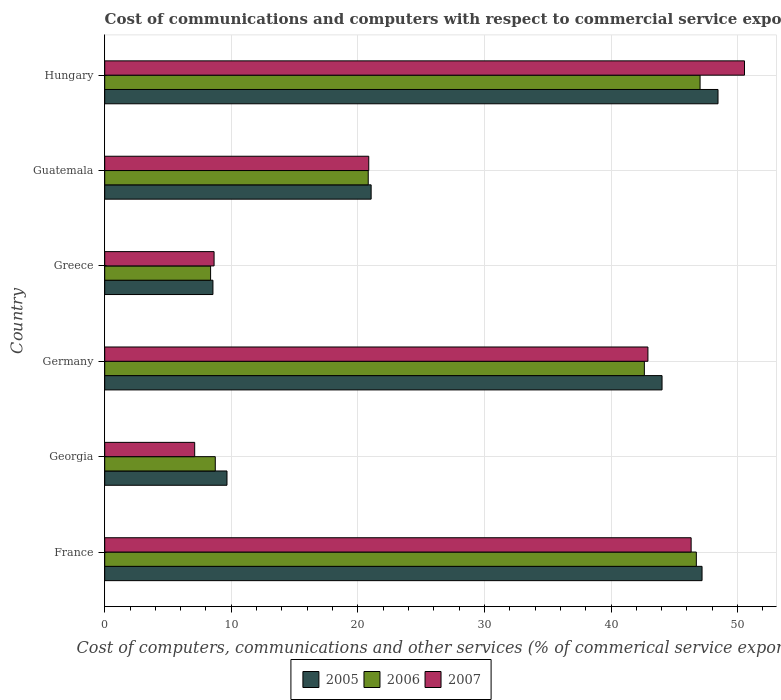How many different coloured bars are there?
Your response must be concise. 3. Are the number of bars on each tick of the Y-axis equal?
Provide a short and direct response. Yes. How many bars are there on the 6th tick from the top?
Provide a short and direct response. 3. How many bars are there on the 5th tick from the bottom?
Give a very brief answer. 3. What is the label of the 4th group of bars from the top?
Ensure brevity in your answer.  Germany. In how many cases, is the number of bars for a given country not equal to the number of legend labels?
Provide a succinct answer. 0. What is the cost of communications and computers in 2005 in Germany?
Provide a short and direct response. 44.03. Across all countries, what is the maximum cost of communications and computers in 2005?
Offer a terse response. 48.46. Across all countries, what is the minimum cost of communications and computers in 2005?
Offer a terse response. 8.55. In which country was the cost of communications and computers in 2005 maximum?
Give a very brief answer. Hungary. In which country was the cost of communications and computers in 2007 minimum?
Your answer should be compact. Georgia. What is the total cost of communications and computers in 2006 in the graph?
Give a very brief answer. 174.34. What is the difference between the cost of communications and computers in 2005 in Georgia and that in Guatemala?
Ensure brevity in your answer.  -11.39. What is the difference between the cost of communications and computers in 2006 in Guatemala and the cost of communications and computers in 2007 in Greece?
Provide a succinct answer. 12.18. What is the average cost of communications and computers in 2006 per country?
Make the answer very short. 29.06. What is the difference between the cost of communications and computers in 2006 and cost of communications and computers in 2005 in Germany?
Your response must be concise. -1.4. What is the ratio of the cost of communications and computers in 2007 in Germany to that in Greece?
Provide a succinct answer. 4.97. Is the difference between the cost of communications and computers in 2006 in Greece and Hungary greater than the difference between the cost of communications and computers in 2005 in Greece and Hungary?
Ensure brevity in your answer.  Yes. What is the difference between the highest and the second highest cost of communications and computers in 2006?
Provide a short and direct response. 0.3. What is the difference between the highest and the lowest cost of communications and computers in 2005?
Your answer should be very brief. 39.9. What does the 3rd bar from the bottom in Germany represents?
Provide a succinct answer. 2007. Is it the case that in every country, the sum of the cost of communications and computers in 2005 and cost of communications and computers in 2007 is greater than the cost of communications and computers in 2006?
Ensure brevity in your answer.  Yes. Are all the bars in the graph horizontal?
Offer a very short reply. Yes. Does the graph contain any zero values?
Give a very brief answer. No. Does the graph contain grids?
Ensure brevity in your answer.  Yes. How are the legend labels stacked?
Keep it short and to the point. Horizontal. What is the title of the graph?
Your response must be concise. Cost of communications and computers with respect to commercial service exports. What is the label or title of the X-axis?
Keep it short and to the point. Cost of computers, communications and other services (% of commerical service exports). What is the label or title of the Y-axis?
Offer a very short reply. Country. What is the Cost of computers, communications and other services (% of commerical service exports) in 2005 in France?
Give a very brief answer. 47.19. What is the Cost of computers, communications and other services (% of commerical service exports) of 2006 in France?
Give a very brief answer. 46.74. What is the Cost of computers, communications and other services (% of commerical service exports) of 2007 in France?
Ensure brevity in your answer.  46.33. What is the Cost of computers, communications and other services (% of commerical service exports) in 2005 in Georgia?
Provide a succinct answer. 9.66. What is the Cost of computers, communications and other services (% of commerical service exports) in 2006 in Georgia?
Give a very brief answer. 8.74. What is the Cost of computers, communications and other services (% of commerical service exports) in 2007 in Georgia?
Make the answer very short. 7.11. What is the Cost of computers, communications and other services (% of commerical service exports) of 2005 in Germany?
Your answer should be compact. 44.03. What is the Cost of computers, communications and other services (% of commerical service exports) in 2006 in Germany?
Give a very brief answer. 42.64. What is the Cost of computers, communications and other services (% of commerical service exports) of 2007 in Germany?
Ensure brevity in your answer.  42.92. What is the Cost of computers, communications and other services (% of commerical service exports) in 2005 in Greece?
Give a very brief answer. 8.55. What is the Cost of computers, communications and other services (% of commerical service exports) of 2006 in Greece?
Your answer should be very brief. 8.36. What is the Cost of computers, communications and other services (% of commerical service exports) in 2007 in Greece?
Give a very brief answer. 8.64. What is the Cost of computers, communications and other services (% of commerical service exports) of 2005 in Guatemala?
Your response must be concise. 21.05. What is the Cost of computers, communications and other services (% of commerical service exports) in 2006 in Guatemala?
Provide a succinct answer. 20.82. What is the Cost of computers, communications and other services (% of commerical service exports) in 2007 in Guatemala?
Keep it short and to the point. 20.86. What is the Cost of computers, communications and other services (% of commerical service exports) of 2005 in Hungary?
Provide a short and direct response. 48.46. What is the Cost of computers, communications and other services (% of commerical service exports) of 2006 in Hungary?
Offer a very short reply. 47.04. What is the Cost of computers, communications and other services (% of commerical service exports) of 2007 in Hungary?
Provide a succinct answer. 50.55. Across all countries, what is the maximum Cost of computers, communications and other services (% of commerical service exports) of 2005?
Offer a terse response. 48.46. Across all countries, what is the maximum Cost of computers, communications and other services (% of commerical service exports) in 2006?
Keep it short and to the point. 47.04. Across all countries, what is the maximum Cost of computers, communications and other services (% of commerical service exports) in 2007?
Your answer should be compact. 50.55. Across all countries, what is the minimum Cost of computers, communications and other services (% of commerical service exports) in 2005?
Give a very brief answer. 8.55. Across all countries, what is the minimum Cost of computers, communications and other services (% of commerical service exports) in 2006?
Give a very brief answer. 8.36. Across all countries, what is the minimum Cost of computers, communications and other services (% of commerical service exports) of 2007?
Your answer should be very brief. 7.11. What is the total Cost of computers, communications and other services (% of commerical service exports) of 2005 in the graph?
Your response must be concise. 178.94. What is the total Cost of computers, communications and other services (% of commerical service exports) of 2006 in the graph?
Provide a short and direct response. 174.34. What is the total Cost of computers, communications and other services (% of commerical service exports) of 2007 in the graph?
Your answer should be compact. 176.41. What is the difference between the Cost of computers, communications and other services (% of commerical service exports) in 2005 in France and that in Georgia?
Offer a very short reply. 37.53. What is the difference between the Cost of computers, communications and other services (% of commerical service exports) in 2006 in France and that in Georgia?
Provide a succinct answer. 38.01. What is the difference between the Cost of computers, communications and other services (% of commerical service exports) in 2007 in France and that in Georgia?
Your answer should be very brief. 39.22. What is the difference between the Cost of computers, communications and other services (% of commerical service exports) in 2005 in France and that in Germany?
Your response must be concise. 3.16. What is the difference between the Cost of computers, communications and other services (% of commerical service exports) in 2006 in France and that in Germany?
Keep it short and to the point. 4.11. What is the difference between the Cost of computers, communications and other services (% of commerical service exports) of 2007 in France and that in Germany?
Offer a very short reply. 3.41. What is the difference between the Cost of computers, communications and other services (% of commerical service exports) in 2005 in France and that in Greece?
Give a very brief answer. 38.64. What is the difference between the Cost of computers, communications and other services (% of commerical service exports) in 2006 in France and that in Greece?
Provide a short and direct response. 38.38. What is the difference between the Cost of computers, communications and other services (% of commerical service exports) in 2007 in France and that in Greece?
Keep it short and to the point. 37.69. What is the difference between the Cost of computers, communications and other services (% of commerical service exports) of 2005 in France and that in Guatemala?
Give a very brief answer. 26.14. What is the difference between the Cost of computers, communications and other services (% of commerical service exports) in 2006 in France and that in Guatemala?
Offer a very short reply. 25.92. What is the difference between the Cost of computers, communications and other services (% of commerical service exports) of 2007 in France and that in Guatemala?
Provide a short and direct response. 25.47. What is the difference between the Cost of computers, communications and other services (% of commerical service exports) of 2005 in France and that in Hungary?
Provide a succinct answer. -1.26. What is the difference between the Cost of computers, communications and other services (% of commerical service exports) of 2006 in France and that in Hungary?
Your response must be concise. -0.3. What is the difference between the Cost of computers, communications and other services (% of commerical service exports) in 2007 in France and that in Hungary?
Make the answer very short. -4.22. What is the difference between the Cost of computers, communications and other services (% of commerical service exports) of 2005 in Georgia and that in Germany?
Give a very brief answer. -34.37. What is the difference between the Cost of computers, communications and other services (% of commerical service exports) in 2006 in Georgia and that in Germany?
Provide a succinct answer. -33.9. What is the difference between the Cost of computers, communications and other services (% of commerical service exports) of 2007 in Georgia and that in Germany?
Provide a succinct answer. -35.81. What is the difference between the Cost of computers, communications and other services (% of commerical service exports) in 2005 in Georgia and that in Greece?
Your answer should be very brief. 1.11. What is the difference between the Cost of computers, communications and other services (% of commerical service exports) in 2006 in Georgia and that in Greece?
Your response must be concise. 0.37. What is the difference between the Cost of computers, communications and other services (% of commerical service exports) of 2007 in Georgia and that in Greece?
Provide a succinct answer. -1.53. What is the difference between the Cost of computers, communications and other services (% of commerical service exports) of 2005 in Georgia and that in Guatemala?
Provide a short and direct response. -11.39. What is the difference between the Cost of computers, communications and other services (% of commerical service exports) in 2006 in Georgia and that in Guatemala?
Ensure brevity in your answer.  -12.08. What is the difference between the Cost of computers, communications and other services (% of commerical service exports) in 2007 in Georgia and that in Guatemala?
Provide a succinct answer. -13.75. What is the difference between the Cost of computers, communications and other services (% of commerical service exports) of 2005 in Georgia and that in Hungary?
Give a very brief answer. -38.8. What is the difference between the Cost of computers, communications and other services (% of commerical service exports) in 2006 in Georgia and that in Hungary?
Provide a succinct answer. -38.3. What is the difference between the Cost of computers, communications and other services (% of commerical service exports) in 2007 in Georgia and that in Hungary?
Your response must be concise. -43.44. What is the difference between the Cost of computers, communications and other services (% of commerical service exports) of 2005 in Germany and that in Greece?
Make the answer very short. 35.48. What is the difference between the Cost of computers, communications and other services (% of commerical service exports) of 2006 in Germany and that in Greece?
Offer a very short reply. 34.27. What is the difference between the Cost of computers, communications and other services (% of commerical service exports) in 2007 in Germany and that in Greece?
Keep it short and to the point. 34.28. What is the difference between the Cost of computers, communications and other services (% of commerical service exports) in 2005 in Germany and that in Guatemala?
Provide a succinct answer. 22.98. What is the difference between the Cost of computers, communications and other services (% of commerical service exports) of 2006 in Germany and that in Guatemala?
Provide a short and direct response. 21.82. What is the difference between the Cost of computers, communications and other services (% of commerical service exports) in 2007 in Germany and that in Guatemala?
Your answer should be very brief. 22.06. What is the difference between the Cost of computers, communications and other services (% of commerical service exports) in 2005 in Germany and that in Hungary?
Give a very brief answer. -4.42. What is the difference between the Cost of computers, communications and other services (% of commerical service exports) in 2006 in Germany and that in Hungary?
Your response must be concise. -4.4. What is the difference between the Cost of computers, communications and other services (% of commerical service exports) in 2007 in Germany and that in Hungary?
Your response must be concise. -7.63. What is the difference between the Cost of computers, communications and other services (% of commerical service exports) in 2005 in Greece and that in Guatemala?
Your answer should be very brief. -12.5. What is the difference between the Cost of computers, communications and other services (% of commerical service exports) of 2006 in Greece and that in Guatemala?
Ensure brevity in your answer.  -12.45. What is the difference between the Cost of computers, communications and other services (% of commerical service exports) in 2007 in Greece and that in Guatemala?
Give a very brief answer. -12.22. What is the difference between the Cost of computers, communications and other services (% of commerical service exports) of 2005 in Greece and that in Hungary?
Offer a very short reply. -39.91. What is the difference between the Cost of computers, communications and other services (% of commerical service exports) of 2006 in Greece and that in Hungary?
Your response must be concise. -38.67. What is the difference between the Cost of computers, communications and other services (% of commerical service exports) of 2007 in Greece and that in Hungary?
Your answer should be very brief. -41.91. What is the difference between the Cost of computers, communications and other services (% of commerical service exports) in 2005 in Guatemala and that in Hungary?
Give a very brief answer. -27.41. What is the difference between the Cost of computers, communications and other services (% of commerical service exports) in 2006 in Guatemala and that in Hungary?
Your response must be concise. -26.22. What is the difference between the Cost of computers, communications and other services (% of commerical service exports) in 2007 in Guatemala and that in Hungary?
Your answer should be very brief. -29.69. What is the difference between the Cost of computers, communications and other services (% of commerical service exports) in 2005 in France and the Cost of computers, communications and other services (% of commerical service exports) in 2006 in Georgia?
Your response must be concise. 38.46. What is the difference between the Cost of computers, communications and other services (% of commerical service exports) in 2005 in France and the Cost of computers, communications and other services (% of commerical service exports) in 2007 in Georgia?
Your answer should be compact. 40.09. What is the difference between the Cost of computers, communications and other services (% of commerical service exports) in 2006 in France and the Cost of computers, communications and other services (% of commerical service exports) in 2007 in Georgia?
Give a very brief answer. 39.64. What is the difference between the Cost of computers, communications and other services (% of commerical service exports) of 2005 in France and the Cost of computers, communications and other services (% of commerical service exports) of 2006 in Germany?
Make the answer very short. 4.56. What is the difference between the Cost of computers, communications and other services (% of commerical service exports) in 2005 in France and the Cost of computers, communications and other services (% of commerical service exports) in 2007 in Germany?
Provide a succinct answer. 4.28. What is the difference between the Cost of computers, communications and other services (% of commerical service exports) of 2006 in France and the Cost of computers, communications and other services (% of commerical service exports) of 2007 in Germany?
Make the answer very short. 3.83. What is the difference between the Cost of computers, communications and other services (% of commerical service exports) of 2005 in France and the Cost of computers, communications and other services (% of commerical service exports) of 2006 in Greece?
Offer a terse response. 38.83. What is the difference between the Cost of computers, communications and other services (% of commerical service exports) in 2005 in France and the Cost of computers, communications and other services (% of commerical service exports) in 2007 in Greece?
Give a very brief answer. 38.55. What is the difference between the Cost of computers, communications and other services (% of commerical service exports) of 2006 in France and the Cost of computers, communications and other services (% of commerical service exports) of 2007 in Greece?
Your answer should be compact. 38.1. What is the difference between the Cost of computers, communications and other services (% of commerical service exports) of 2005 in France and the Cost of computers, communications and other services (% of commerical service exports) of 2006 in Guatemala?
Give a very brief answer. 26.37. What is the difference between the Cost of computers, communications and other services (% of commerical service exports) of 2005 in France and the Cost of computers, communications and other services (% of commerical service exports) of 2007 in Guatemala?
Offer a terse response. 26.33. What is the difference between the Cost of computers, communications and other services (% of commerical service exports) of 2006 in France and the Cost of computers, communications and other services (% of commerical service exports) of 2007 in Guatemala?
Provide a succinct answer. 25.88. What is the difference between the Cost of computers, communications and other services (% of commerical service exports) in 2005 in France and the Cost of computers, communications and other services (% of commerical service exports) in 2006 in Hungary?
Provide a short and direct response. 0.16. What is the difference between the Cost of computers, communications and other services (% of commerical service exports) in 2005 in France and the Cost of computers, communications and other services (% of commerical service exports) in 2007 in Hungary?
Provide a short and direct response. -3.35. What is the difference between the Cost of computers, communications and other services (% of commerical service exports) in 2006 in France and the Cost of computers, communications and other services (% of commerical service exports) in 2007 in Hungary?
Make the answer very short. -3.8. What is the difference between the Cost of computers, communications and other services (% of commerical service exports) of 2005 in Georgia and the Cost of computers, communications and other services (% of commerical service exports) of 2006 in Germany?
Your answer should be compact. -32.98. What is the difference between the Cost of computers, communications and other services (% of commerical service exports) of 2005 in Georgia and the Cost of computers, communications and other services (% of commerical service exports) of 2007 in Germany?
Ensure brevity in your answer.  -33.26. What is the difference between the Cost of computers, communications and other services (% of commerical service exports) of 2006 in Georgia and the Cost of computers, communications and other services (% of commerical service exports) of 2007 in Germany?
Keep it short and to the point. -34.18. What is the difference between the Cost of computers, communications and other services (% of commerical service exports) of 2005 in Georgia and the Cost of computers, communications and other services (% of commerical service exports) of 2006 in Greece?
Give a very brief answer. 1.3. What is the difference between the Cost of computers, communications and other services (% of commerical service exports) in 2005 in Georgia and the Cost of computers, communications and other services (% of commerical service exports) in 2007 in Greece?
Keep it short and to the point. 1.02. What is the difference between the Cost of computers, communications and other services (% of commerical service exports) in 2006 in Georgia and the Cost of computers, communications and other services (% of commerical service exports) in 2007 in Greece?
Provide a succinct answer. 0.1. What is the difference between the Cost of computers, communications and other services (% of commerical service exports) in 2005 in Georgia and the Cost of computers, communications and other services (% of commerical service exports) in 2006 in Guatemala?
Provide a succinct answer. -11.16. What is the difference between the Cost of computers, communications and other services (% of commerical service exports) in 2005 in Georgia and the Cost of computers, communications and other services (% of commerical service exports) in 2007 in Guatemala?
Your answer should be very brief. -11.2. What is the difference between the Cost of computers, communications and other services (% of commerical service exports) of 2006 in Georgia and the Cost of computers, communications and other services (% of commerical service exports) of 2007 in Guatemala?
Provide a short and direct response. -12.13. What is the difference between the Cost of computers, communications and other services (% of commerical service exports) in 2005 in Georgia and the Cost of computers, communications and other services (% of commerical service exports) in 2006 in Hungary?
Offer a very short reply. -37.38. What is the difference between the Cost of computers, communications and other services (% of commerical service exports) in 2005 in Georgia and the Cost of computers, communications and other services (% of commerical service exports) in 2007 in Hungary?
Provide a succinct answer. -40.89. What is the difference between the Cost of computers, communications and other services (% of commerical service exports) of 2006 in Georgia and the Cost of computers, communications and other services (% of commerical service exports) of 2007 in Hungary?
Your answer should be very brief. -41.81. What is the difference between the Cost of computers, communications and other services (% of commerical service exports) of 2005 in Germany and the Cost of computers, communications and other services (% of commerical service exports) of 2006 in Greece?
Your answer should be compact. 35.67. What is the difference between the Cost of computers, communications and other services (% of commerical service exports) in 2005 in Germany and the Cost of computers, communications and other services (% of commerical service exports) in 2007 in Greece?
Your answer should be very brief. 35.39. What is the difference between the Cost of computers, communications and other services (% of commerical service exports) of 2006 in Germany and the Cost of computers, communications and other services (% of commerical service exports) of 2007 in Greece?
Give a very brief answer. 34. What is the difference between the Cost of computers, communications and other services (% of commerical service exports) in 2005 in Germany and the Cost of computers, communications and other services (% of commerical service exports) in 2006 in Guatemala?
Give a very brief answer. 23.21. What is the difference between the Cost of computers, communications and other services (% of commerical service exports) in 2005 in Germany and the Cost of computers, communications and other services (% of commerical service exports) in 2007 in Guatemala?
Keep it short and to the point. 23.17. What is the difference between the Cost of computers, communications and other services (% of commerical service exports) in 2006 in Germany and the Cost of computers, communications and other services (% of commerical service exports) in 2007 in Guatemala?
Offer a terse response. 21.78. What is the difference between the Cost of computers, communications and other services (% of commerical service exports) of 2005 in Germany and the Cost of computers, communications and other services (% of commerical service exports) of 2006 in Hungary?
Your answer should be compact. -3.01. What is the difference between the Cost of computers, communications and other services (% of commerical service exports) in 2005 in Germany and the Cost of computers, communications and other services (% of commerical service exports) in 2007 in Hungary?
Keep it short and to the point. -6.52. What is the difference between the Cost of computers, communications and other services (% of commerical service exports) of 2006 in Germany and the Cost of computers, communications and other services (% of commerical service exports) of 2007 in Hungary?
Offer a terse response. -7.91. What is the difference between the Cost of computers, communications and other services (% of commerical service exports) of 2005 in Greece and the Cost of computers, communications and other services (% of commerical service exports) of 2006 in Guatemala?
Your answer should be very brief. -12.27. What is the difference between the Cost of computers, communications and other services (% of commerical service exports) in 2005 in Greece and the Cost of computers, communications and other services (% of commerical service exports) in 2007 in Guatemala?
Provide a succinct answer. -12.31. What is the difference between the Cost of computers, communications and other services (% of commerical service exports) of 2006 in Greece and the Cost of computers, communications and other services (% of commerical service exports) of 2007 in Guatemala?
Keep it short and to the point. -12.5. What is the difference between the Cost of computers, communications and other services (% of commerical service exports) of 2005 in Greece and the Cost of computers, communications and other services (% of commerical service exports) of 2006 in Hungary?
Offer a terse response. -38.49. What is the difference between the Cost of computers, communications and other services (% of commerical service exports) in 2005 in Greece and the Cost of computers, communications and other services (% of commerical service exports) in 2007 in Hungary?
Offer a very short reply. -42. What is the difference between the Cost of computers, communications and other services (% of commerical service exports) in 2006 in Greece and the Cost of computers, communications and other services (% of commerical service exports) in 2007 in Hungary?
Your answer should be very brief. -42.18. What is the difference between the Cost of computers, communications and other services (% of commerical service exports) of 2005 in Guatemala and the Cost of computers, communications and other services (% of commerical service exports) of 2006 in Hungary?
Your answer should be compact. -25.99. What is the difference between the Cost of computers, communications and other services (% of commerical service exports) of 2005 in Guatemala and the Cost of computers, communications and other services (% of commerical service exports) of 2007 in Hungary?
Make the answer very short. -29.5. What is the difference between the Cost of computers, communications and other services (% of commerical service exports) of 2006 in Guatemala and the Cost of computers, communications and other services (% of commerical service exports) of 2007 in Hungary?
Provide a short and direct response. -29.73. What is the average Cost of computers, communications and other services (% of commerical service exports) in 2005 per country?
Keep it short and to the point. 29.82. What is the average Cost of computers, communications and other services (% of commerical service exports) of 2006 per country?
Ensure brevity in your answer.  29.06. What is the average Cost of computers, communications and other services (% of commerical service exports) of 2007 per country?
Provide a short and direct response. 29.4. What is the difference between the Cost of computers, communications and other services (% of commerical service exports) of 2005 and Cost of computers, communications and other services (% of commerical service exports) of 2006 in France?
Provide a succinct answer. 0.45. What is the difference between the Cost of computers, communications and other services (% of commerical service exports) of 2005 and Cost of computers, communications and other services (% of commerical service exports) of 2007 in France?
Provide a succinct answer. 0.86. What is the difference between the Cost of computers, communications and other services (% of commerical service exports) in 2006 and Cost of computers, communications and other services (% of commerical service exports) in 2007 in France?
Provide a short and direct response. 0.41. What is the difference between the Cost of computers, communications and other services (% of commerical service exports) in 2005 and Cost of computers, communications and other services (% of commerical service exports) in 2006 in Georgia?
Ensure brevity in your answer.  0.93. What is the difference between the Cost of computers, communications and other services (% of commerical service exports) in 2005 and Cost of computers, communications and other services (% of commerical service exports) in 2007 in Georgia?
Provide a succinct answer. 2.55. What is the difference between the Cost of computers, communications and other services (% of commerical service exports) of 2006 and Cost of computers, communications and other services (% of commerical service exports) of 2007 in Georgia?
Make the answer very short. 1.63. What is the difference between the Cost of computers, communications and other services (% of commerical service exports) in 2005 and Cost of computers, communications and other services (% of commerical service exports) in 2006 in Germany?
Provide a succinct answer. 1.4. What is the difference between the Cost of computers, communications and other services (% of commerical service exports) of 2005 and Cost of computers, communications and other services (% of commerical service exports) of 2007 in Germany?
Keep it short and to the point. 1.11. What is the difference between the Cost of computers, communications and other services (% of commerical service exports) in 2006 and Cost of computers, communications and other services (% of commerical service exports) in 2007 in Germany?
Provide a succinct answer. -0.28. What is the difference between the Cost of computers, communications and other services (% of commerical service exports) in 2005 and Cost of computers, communications and other services (% of commerical service exports) in 2006 in Greece?
Make the answer very short. 0.19. What is the difference between the Cost of computers, communications and other services (% of commerical service exports) in 2005 and Cost of computers, communications and other services (% of commerical service exports) in 2007 in Greece?
Keep it short and to the point. -0.09. What is the difference between the Cost of computers, communications and other services (% of commerical service exports) of 2006 and Cost of computers, communications and other services (% of commerical service exports) of 2007 in Greece?
Your answer should be compact. -0.28. What is the difference between the Cost of computers, communications and other services (% of commerical service exports) in 2005 and Cost of computers, communications and other services (% of commerical service exports) in 2006 in Guatemala?
Your answer should be compact. 0.23. What is the difference between the Cost of computers, communications and other services (% of commerical service exports) in 2005 and Cost of computers, communications and other services (% of commerical service exports) in 2007 in Guatemala?
Offer a terse response. 0.19. What is the difference between the Cost of computers, communications and other services (% of commerical service exports) in 2006 and Cost of computers, communications and other services (% of commerical service exports) in 2007 in Guatemala?
Ensure brevity in your answer.  -0.04. What is the difference between the Cost of computers, communications and other services (% of commerical service exports) in 2005 and Cost of computers, communications and other services (% of commerical service exports) in 2006 in Hungary?
Ensure brevity in your answer.  1.42. What is the difference between the Cost of computers, communications and other services (% of commerical service exports) in 2005 and Cost of computers, communications and other services (% of commerical service exports) in 2007 in Hungary?
Your response must be concise. -2.09. What is the difference between the Cost of computers, communications and other services (% of commerical service exports) of 2006 and Cost of computers, communications and other services (% of commerical service exports) of 2007 in Hungary?
Your answer should be very brief. -3.51. What is the ratio of the Cost of computers, communications and other services (% of commerical service exports) of 2005 in France to that in Georgia?
Give a very brief answer. 4.89. What is the ratio of the Cost of computers, communications and other services (% of commerical service exports) in 2006 in France to that in Georgia?
Keep it short and to the point. 5.35. What is the ratio of the Cost of computers, communications and other services (% of commerical service exports) in 2007 in France to that in Georgia?
Ensure brevity in your answer.  6.52. What is the ratio of the Cost of computers, communications and other services (% of commerical service exports) in 2005 in France to that in Germany?
Your answer should be very brief. 1.07. What is the ratio of the Cost of computers, communications and other services (% of commerical service exports) of 2006 in France to that in Germany?
Ensure brevity in your answer.  1.1. What is the ratio of the Cost of computers, communications and other services (% of commerical service exports) of 2007 in France to that in Germany?
Offer a very short reply. 1.08. What is the ratio of the Cost of computers, communications and other services (% of commerical service exports) of 2005 in France to that in Greece?
Give a very brief answer. 5.52. What is the ratio of the Cost of computers, communications and other services (% of commerical service exports) in 2006 in France to that in Greece?
Provide a succinct answer. 5.59. What is the ratio of the Cost of computers, communications and other services (% of commerical service exports) in 2007 in France to that in Greece?
Your response must be concise. 5.36. What is the ratio of the Cost of computers, communications and other services (% of commerical service exports) in 2005 in France to that in Guatemala?
Your answer should be compact. 2.24. What is the ratio of the Cost of computers, communications and other services (% of commerical service exports) of 2006 in France to that in Guatemala?
Keep it short and to the point. 2.25. What is the ratio of the Cost of computers, communications and other services (% of commerical service exports) of 2007 in France to that in Guatemala?
Make the answer very short. 2.22. What is the ratio of the Cost of computers, communications and other services (% of commerical service exports) of 2005 in France to that in Hungary?
Ensure brevity in your answer.  0.97. What is the ratio of the Cost of computers, communications and other services (% of commerical service exports) in 2007 in France to that in Hungary?
Provide a short and direct response. 0.92. What is the ratio of the Cost of computers, communications and other services (% of commerical service exports) in 2005 in Georgia to that in Germany?
Keep it short and to the point. 0.22. What is the ratio of the Cost of computers, communications and other services (% of commerical service exports) in 2006 in Georgia to that in Germany?
Your answer should be very brief. 0.2. What is the ratio of the Cost of computers, communications and other services (% of commerical service exports) of 2007 in Georgia to that in Germany?
Ensure brevity in your answer.  0.17. What is the ratio of the Cost of computers, communications and other services (% of commerical service exports) in 2005 in Georgia to that in Greece?
Offer a very short reply. 1.13. What is the ratio of the Cost of computers, communications and other services (% of commerical service exports) in 2006 in Georgia to that in Greece?
Your response must be concise. 1.04. What is the ratio of the Cost of computers, communications and other services (% of commerical service exports) of 2007 in Georgia to that in Greece?
Give a very brief answer. 0.82. What is the ratio of the Cost of computers, communications and other services (% of commerical service exports) of 2005 in Georgia to that in Guatemala?
Make the answer very short. 0.46. What is the ratio of the Cost of computers, communications and other services (% of commerical service exports) in 2006 in Georgia to that in Guatemala?
Provide a short and direct response. 0.42. What is the ratio of the Cost of computers, communications and other services (% of commerical service exports) of 2007 in Georgia to that in Guatemala?
Make the answer very short. 0.34. What is the ratio of the Cost of computers, communications and other services (% of commerical service exports) of 2005 in Georgia to that in Hungary?
Your answer should be very brief. 0.2. What is the ratio of the Cost of computers, communications and other services (% of commerical service exports) in 2006 in Georgia to that in Hungary?
Your answer should be compact. 0.19. What is the ratio of the Cost of computers, communications and other services (% of commerical service exports) in 2007 in Georgia to that in Hungary?
Offer a terse response. 0.14. What is the ratio of the Cost of computers, communications and other services (% of commerical service exports) in 2005 in Germany to that in Greece?
Keep it short and to the point. 5.15. What is the ratio of the Cost of computers, communications and other services (% of commerical service exports) in 2006 in Germany to that in Greece?
Keep it short and to the point. 5.1. What is the ratio of the Cost of computers, communications and other services (% of commerical service exports) in 2007 in Germany to that in Greece?
Offer a terse response. 4.97. What is the ratio of the Cost of computers, communications and other services (% of commerical service exports) of 2005 in Germany to that in Guatemala?
Your answer should be compact. 2.09. What is the ratio of the Cost of computers, communications and other services (% of commerical service exports) in 2006 in Germany to that in Guatemala?
Your response must be concise. 2.05. What is the ratio of the Cost of computers, communications and other services (% of commerical service exports) of 2007 in Germany to that in Guatemala?
Offer a very short reply. 2.06. What is the ratio of the Cost of computers, communications and other services (% of commerical service exports) of 2005 in Germany to that in Hungary?
Give a very brief answer. 0.91. What is the ratio of the Cost of computers, communications and other services (% of commerical service exports) in 2006 in Germany to that in Hungary?
Your answer should be compact. 0.91. What is the ratio of the Cost of computers, communications and other services (% of commerical service exports) of 2007 in Germany to that in Hungary?
Your answer should be compact. 0.85. What is the ratio of the Cost of computers, communications and other services (% of commerical service exports) of 2005 in Greece to that in Guatemala?
Ensure brevity in your answer.  0.41. What is the ratio of the Cost of computers, communications and other services (% of commerical service exports) of 2006 in Greece to that in Guatemala?
Make the answer very short. 0.4. What is the ratio of the Cost of computers, communications and other services (% of commerical service exports) of 2007 in Greece to that in Guatemala?
Give a very brief answer. 0.41. What is the ratio of the Cost of computers, communications and other services (% of commerical service exports) in 2005 in Greece to that in Hungary?
Make the answer very short. 0.18. What is the ratio of the Cost of computers, communications and other services (% of commerical service exports) in 2006 in Greece to that in Hungary?
Make the answer very short. 0.18. What is the ratio of the Cost of computers, communications and other services (% of commerical service exports) of 2007 in Greece to that in Hungary?
Offer a very short reply. 0.17. What is the ratio of the Cost of computers, communications and other services (% of commerical service exports) of 2005 in Guatemala to that in Hungary?
Offer a very short reply. 0.43. What is the ratio of the Cost of computers, communications and other services (% of commerical service exports) in 2006 in Guatemala to that in Hungary?
Make the answer very short. 0.44. What is the ratio of the Cost of computers, communications and other services (% of commerical service exports) of 2007 in Guatemala to that in Hungary?
Ensure brevity in your answer.  0.41. What is the difference between the highest and the second highest Cost of computers, communications and other services (% of commerical service exports) of 2005?
Keep it short and to the point. 1.26. What is the difference between the highest and the second highest Cost of computers, communications and other services (% of commerical service exports) in 2006?
Offer a terse response. 0.3. What is the difference between the highest and the second highest Cost of computers, communications and other services (% of commerical service exports) of 2007?
Your response must be concise. 4.22. What is the difference between the highest and the lowest Cost of computers, communications and other services (% of commerical service exports) of 2005?
Offer a very short reply. 39.91. What is the difference between the highest and the lowest Cost of computers, communications and other services (% of commerical service exports) in 2006?
Provide a short and direct response. 38.67. What is the difference between the highest and the lowest Cost of computers, communications and other services (% of commerical service exports) of 2007?
Your response must be concise. 43.44. 